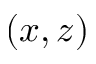<formula> <loc_0><loc_0><loc_500><loc_500>( x , z )</formula> 